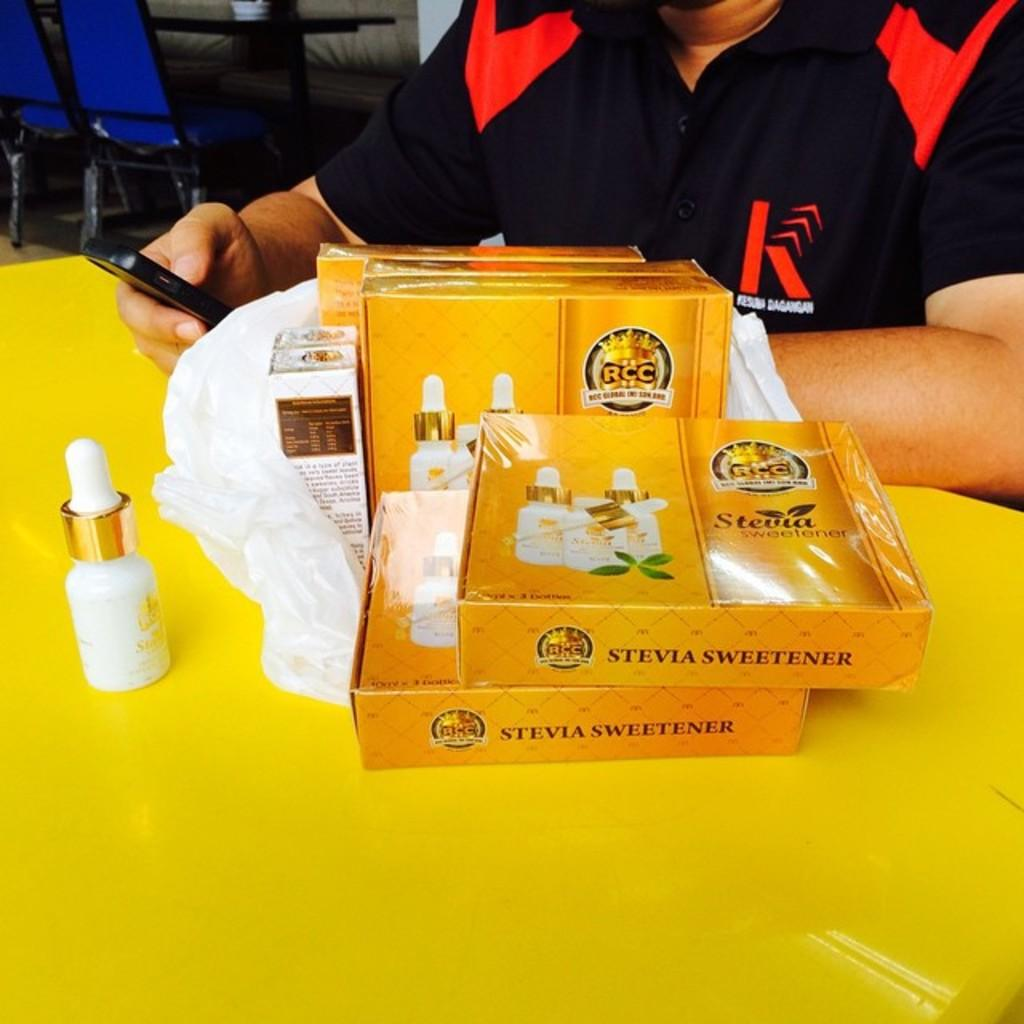<image>
Render a clear and concise summary of the photo. a yellow box with the word stevia on it 